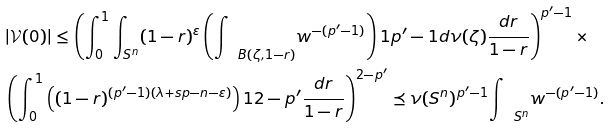Convert formula to latex. <formula><loc_0><loc_0><loc_500><loc_500>& | { \mathcal { V } } ( 0 ) | \leq \left ( \int _ { 0 } ^ { 1 } \int _ { { S } ^ { n } } ( 1 - r ) ^ { \varepsilon } \left ( { \int \, \ } _ { B ( \zeta , 1 - r ) } w ^ { - ( p ^ { \prime } - 1 ) } \right ) ^ { } { 1 } { p ^ { \prime } - 1 } d \nu ( \zeta ) \frac { d r } { 1 - r } \right ) ^ { p ^ { \prime } - 1 } \times \\ & \left ( \int _ { 0 } ^ { 1 } \left ( ( 1 - r ) ^ { ( p ^ { \prime } - 1 ) ( \lambda + s p - n - \varepsilon ) } \right ) ^ { } { 1 } { 2 - p ^ { \prime } } \frac { d r } { 1 - r } \right ) ^ { 2 - p ^ { \prime } } \preceq \nu ( { S } ^ { n } ) ^ { p ^ { \prime } - 1 } { \int \, \ } _ { { S } ^ { n } } w ^ { - { ( p ^ { \prime } - 1 ) } } .</formula> 